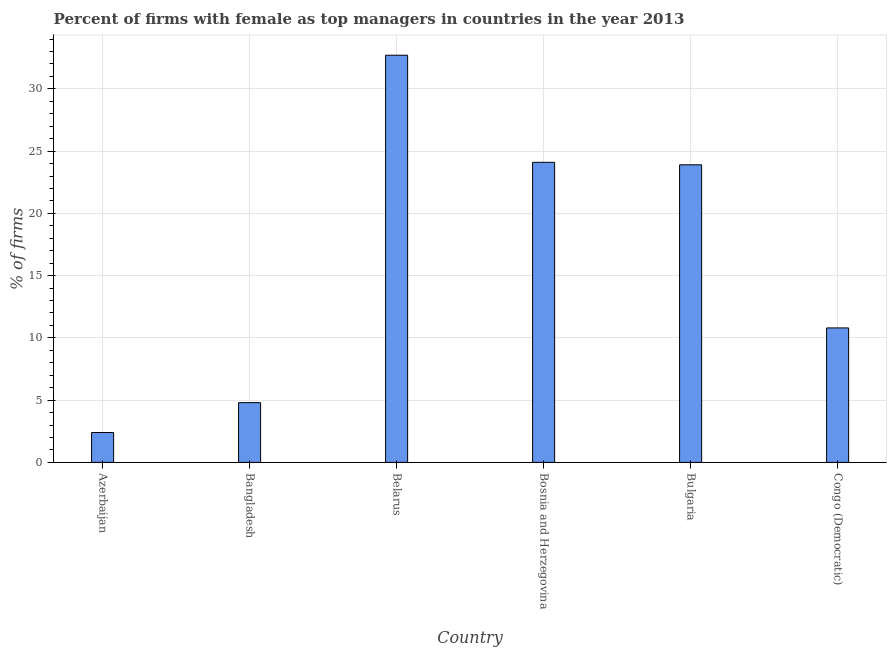Does the graph contain grids?
Your response must be concise. Yes. What is the title of the graph?
Ensure brevity in your answer.  Percent of firms with female as top managers in countries in the year 2013. What is the label or title of the X-axis?
Your answer should be compact. Country. What is the label or title of the Y-axis?
Give a very brief answer. % of firms. What is the percentage of firms with female as top manager in Congo (Democratic)?
Provide a short and direct response. 10.8. Across all countries, what is the maximum percentage of firms with female as top manager?
Your answer should be very brief. 32.7. In which country was the percentage of firms with female as top manager maximum?
Provide a succinct answer. Belarus. In which country was the percentage of firms with female as top manager minimum?
Offer a very short reply. Azerbaijan. What is the sum of the percentage of firms with female as top manager?
Make the answer very short. 98.7. What is the difference between the percentage of firms with female as top manager in Azerbaijan and Bulgaria?
Provide a short and direct response. -21.5. What is the average percentage of firms with female as top manager per country?
Your response must be concise. 16.45. What is the median percentage of firms with female as top manager?
Your answer should be very brief. 17.35. In how many countries, is the percentage of firms with female as top manager greater than 23 %?
Make the answer very short. 3. What is the ratio of the percentage of firms with female as top manager in Bangladesh to that in Congo (Democratic)?
Make the answer very short. 0.44. Is the percentage of firms with female as top manager in Bosnia and Herzegovina less than that in Bulgaria?
Your answer should be compact. No. Is the difference between the percentage of firms with female as top manager in Bangladesh and Bosnia and Herzegovina greater than the difference between any two countries?
Offer a terse response. No. What is the difference between the highest and the second highest percentage of firms with female as top manager?
Give a very brief answer. 8.6. What is the difference between the highest and the lowest percentage of firms with female as top manager?
Your answer should be compact. 30.3. In how many countries, is the percentage of firms with female as top manager greater than the average percentage of firms with female as top manager taken over all countries?
Provide a succinct answer. 3. How many countries are there in the graph?
Provide a succinct answer. 6. What is the % of firms of Azerbaijan?
Offer a terse response. 2.4. What is the % of firms in Belarus?
Your answer should be compact. 32.7. What is the % of firms of Bosnia and Herzegovina?
Your answer should be compact. 24.1. What is the % of firms in Bulgaria?
Offer a very short reply. 23.9. What is the difference between the % of firms in Azerbaijan and Bangladesh?
Give a very brief answer. -2.4. What is the difference between the % of firms in Azerbaijan and Belarus?
Your answer should be compact. -30.3. What is the difference between the % of firms in Azerbaijan and Bosnia and Herzegovina?
Give a very brief answer. -21.7. What is the difference between the % of firms in Azerbaijan and Bulgaria?
Give a very brief answer. -21.5. What is the difference between the % of firms in Bangladesh and Belarus?
Your response must be concise. -27.9. What is the difference between the % of firms in Bangladesh and Bosnia and Herzegovina?
Offer a very short reply. -19.3. What is the difference between the % of firms in Bangladesh and Bulgaria?
Provide a succinct answer. -19.1. What is the difference between the % of firms in Belarus and Congo (Democratic)?
Your response must be concise. 21.9. What is the difference between the % of firms in Bosnia and Herzegovina and Bulgaria?
Provide a short and direct response. 0.2. What is the difference between the % of firms in Bulgaria and Congo (Democratic)?
Make the answer very short. 13.1. What is the ratio of the % of firms in Azerbaijan to that in Belarus?
Your answer should be very brief. 0.07. What is the ratio of the % of firms in Azerbaijan to that in Congo (Democratic)?
Offer a very short reply. 0.22. What is the ratio of the % of firms in Bangladesh to that in Belarus?
Your response must be concise. 0.15. What is the ratio of the % of firms in Bangladesh to that in Bosnia and Herzegovina?
Offer a very short reply. 0.2. What is the ratio of the % of firms in Bangladesh to that in Bulgaria?
Provide a succinct answer. 0.2. What is the ratio of the % of firms in Bangladesh to that in Congo (Democratic)?
Keep it short and to the point. 0.44. What is the ratio of the % of firms in Belarus to that in Bosnia and Herzegovina?
Offer a very short reply. 1.36. What is the ratio of the % of firms in Belarus to that in Bulgaria?
Your answer should be very brief. 1.37. What is the ratio of the % of firms in Belarus to that in Congo (Democratic)?
Your answer should be compact. 3.03. What is the ratio of the % of firms in Bosnia and Herzegovina to that in Bulgaria?
Provide a succinct answer. 1.01. What is the ratio of the % of firms in Bosnia and Herzegovina to that in Congo (Democratic)?
Provide a succinct answer. 2.23. What is the ratio of the % of firms in Bulgaria to that in Congo (Democratic)?
Ensure brevity in your answer.  2.21. 